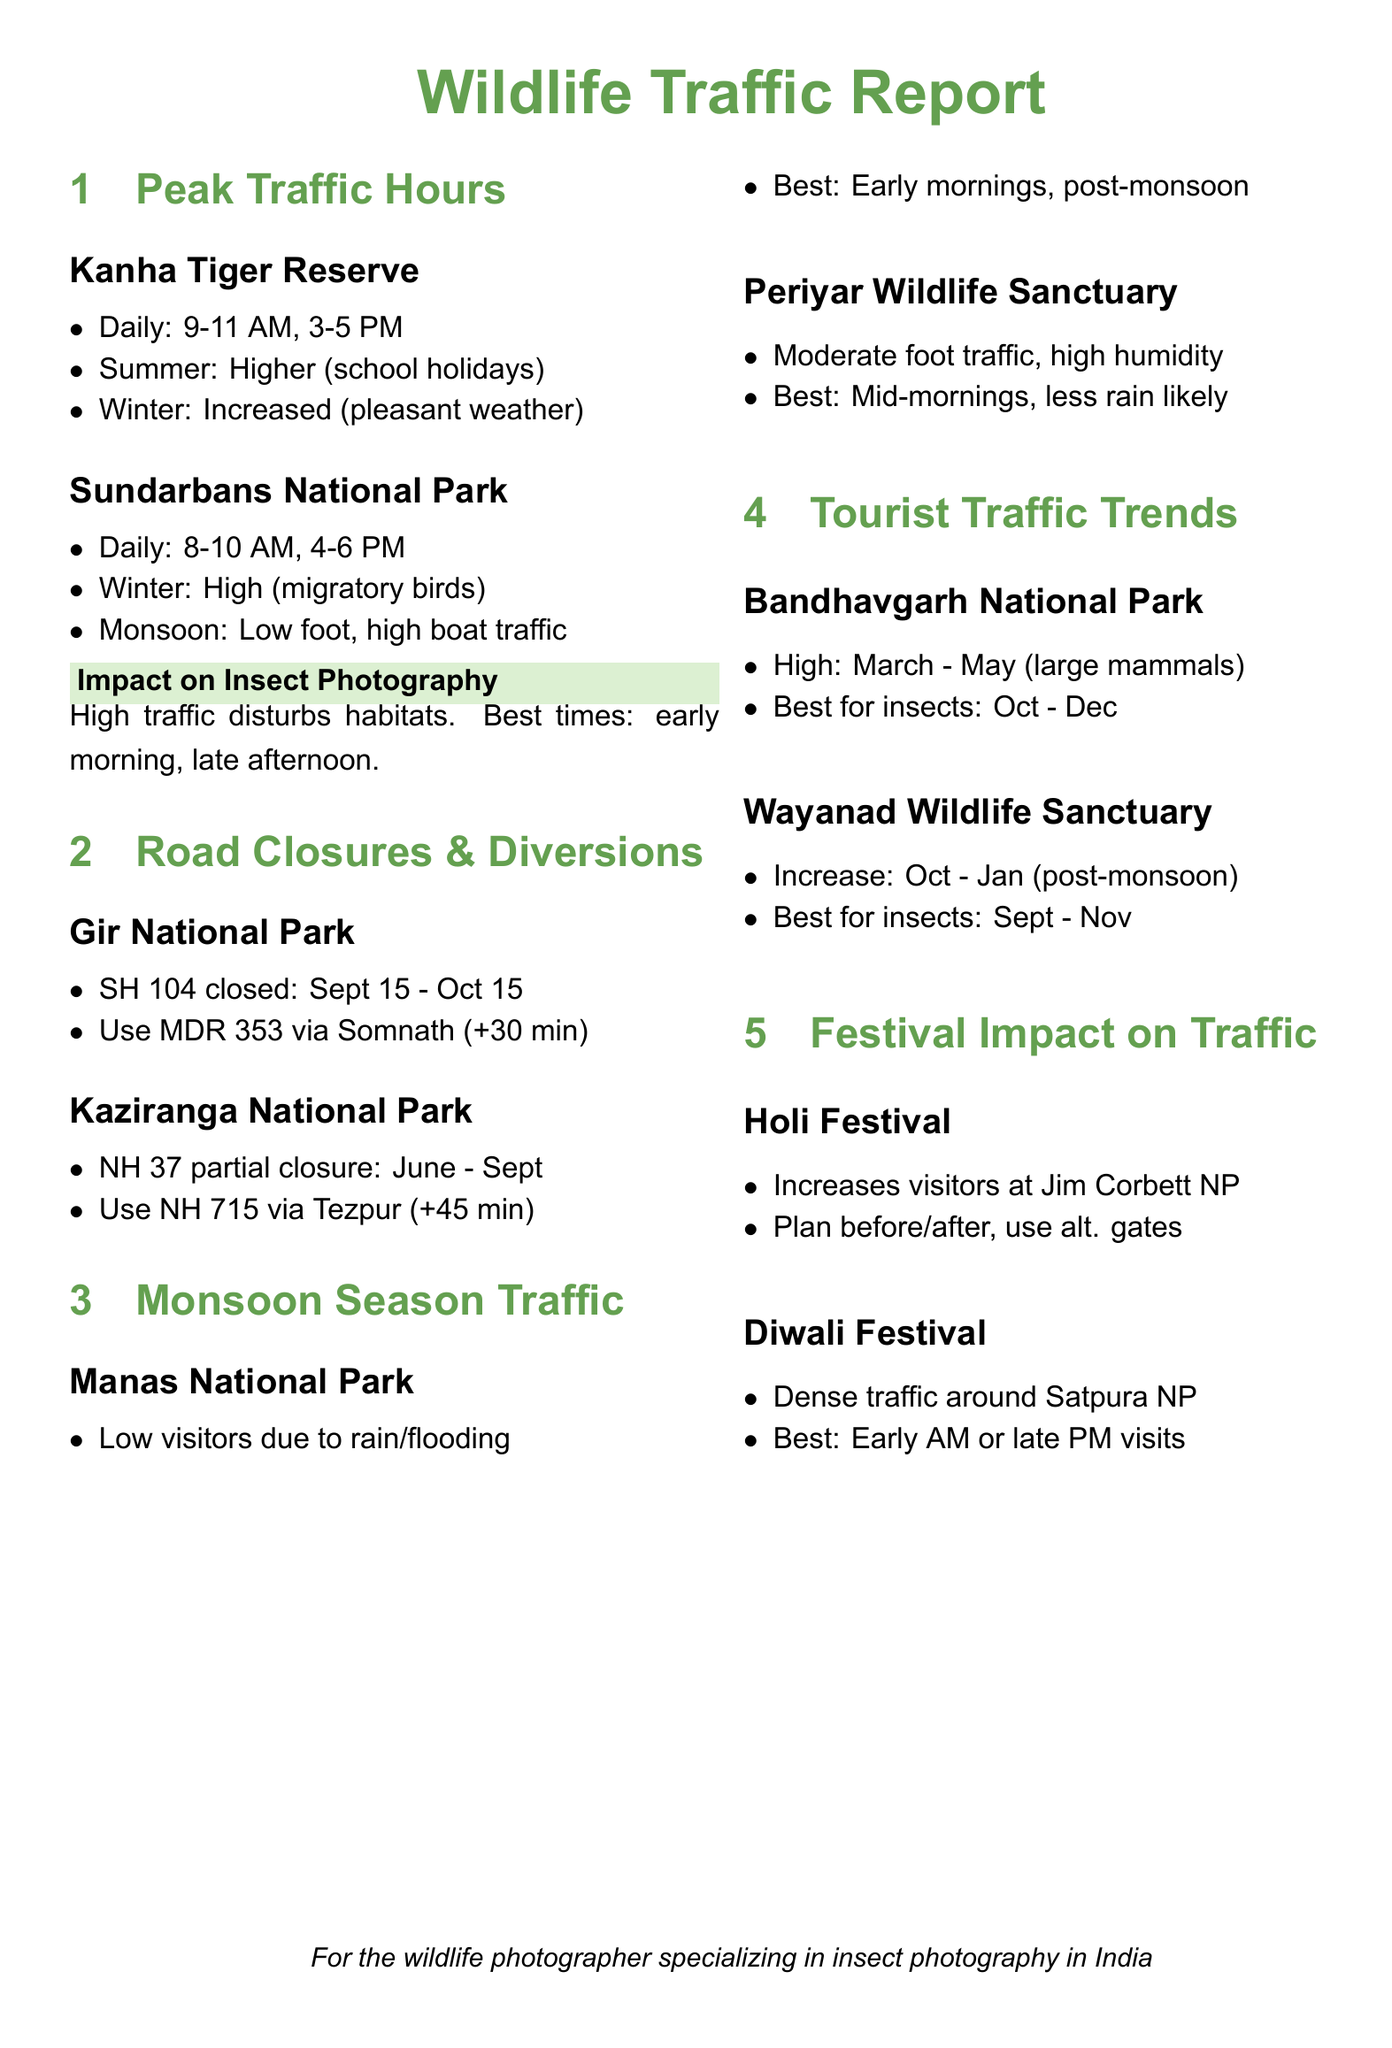What are the peak traffic hours at Kanha Tiger Reserve? The document lists the peak traffic hours for Kanha Tiger Reserve as daily from 9-11 AM and 3-5 PM.
Answer: 9-11 AM, 3-5 PM What is the alternate route during the road closure at Gir National Park? The document states to use MDR 353 via Somnath during the closure of SH 104.
Answer: MDR 353 via Somnath What is the best time for insect photography at Bandhavgarh National Park? The document mentions that the best time for insects at Bandhavgarh National Park is from October to December.
Answer: October - December When does traffic density increase at Wayanad Wildlife Sanctuary? The document indicates an increase in tourist traffic at Wayanad Wildlife Sanctuary from October to January.
Answer: October - January What impact does Holi Festival have on traffic at Jim Corbett National Park? The document notes that Holi Festival increases visitors at Jim Corbett National Park.
Answer: Increases visitors What is the best time to visit during the monsoon at Manas National Park? According to the document, the best time to visit Manas National Park during the monsoon is early mornings, post-monsoon.
Answer: Early mornings, post-monsoon What season sees high traffic at Sundarbans National Park? The document indicates high traffic at Sundarbans National Park during winter, especially due to migratory birds.
Answer: Winter Which road is partially closed near Kaziranga National Park? The document identifies NH 37 as partially closed near Kaziranga National Park from June to September.
Answer: NH 37 What is the suggested visiting time during Diwali Festival at Satpura National Park? The document advises that the best visiting times during Diwali Festival at Satpura National Park are early morning or late evening.
Answer: Early AM or late PM visits 